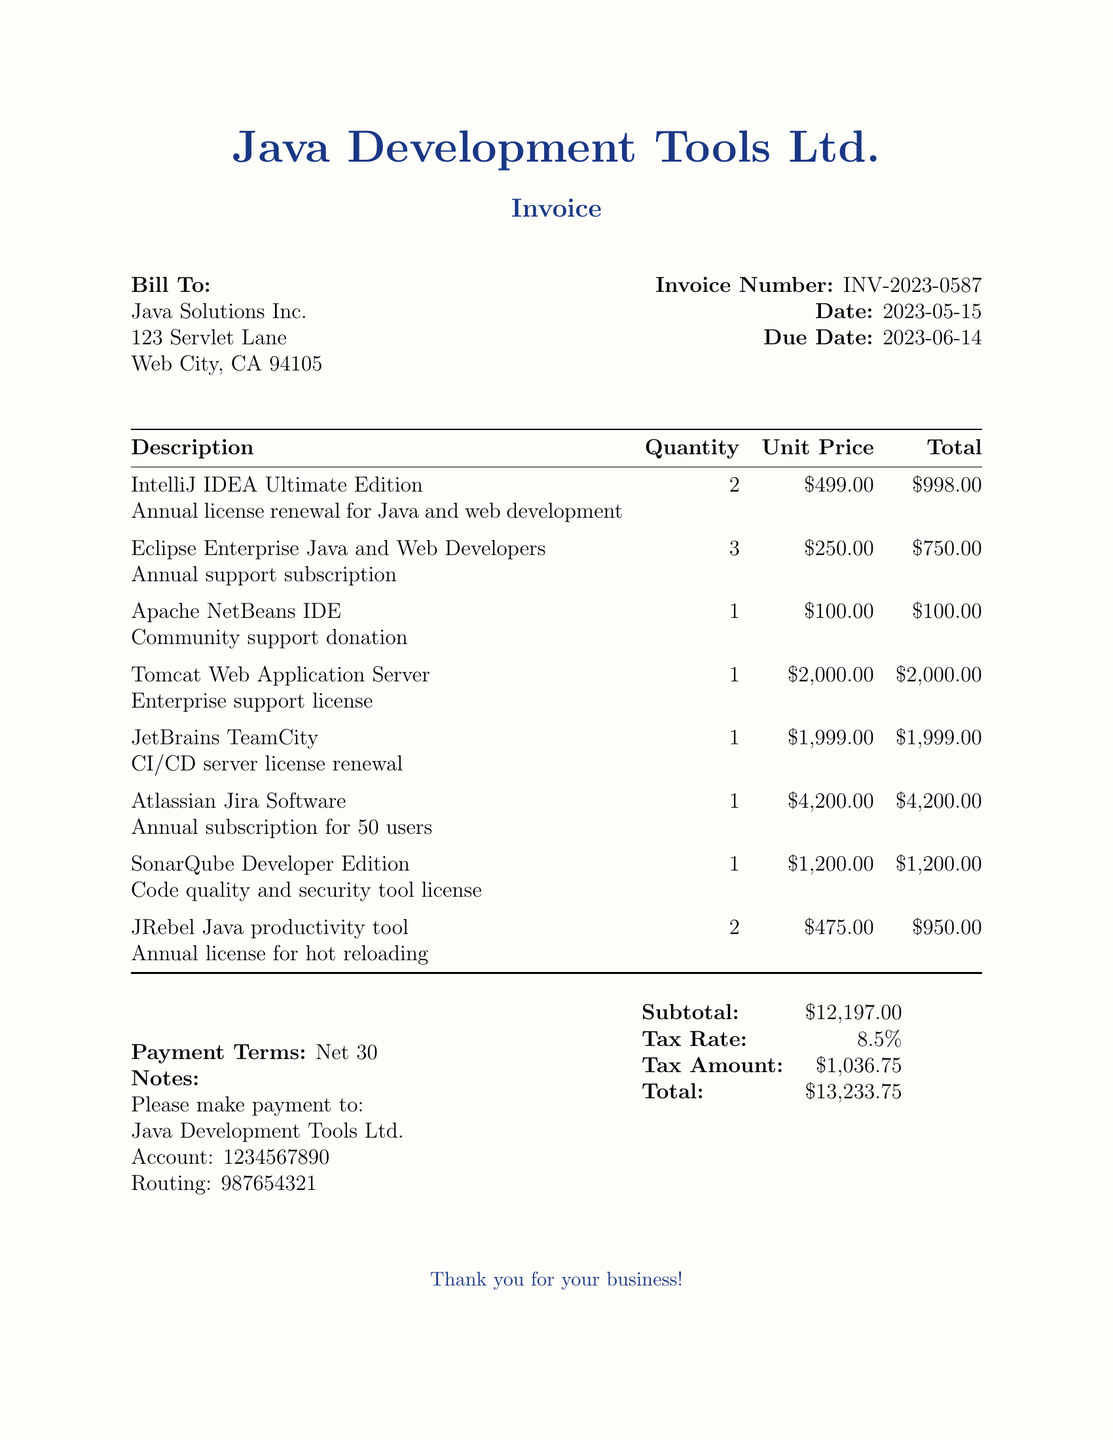What is the invoice number? The invoice number is explicitly stated at the top of the document.
Answer: INV-2023-0587 What is the total amount due? The total amount is the final total listed at the bottom of the invoice.
Answer: $13,233.75 What is the due date for payment? The due date is mentioned alongside the invoice date.
Answer: 2023-06-14 How many licenses were renewed for IntelliJ IDEA? The quantity of IntelliJ IDEA licenses is listed in the itemized costs section.
Answer: 2 What is the description of the Tomcat Web Application Server? The description is provided directly beneath the item in the itemized list.
Answer: Enterprise support license What is the name of the customer? The customer name is prominently displayed in the billing section of the invoice.
Answer: Java Solutions Inc How much is the tax amount? The tax amount is clearly indicated in the financial summary area at the bottom of the document.
Answer: $1,036.75 What is the payment term specified in the invoice? The payment terms are listed in the notes section.
Answer: Net 30 How many users does the Atlassian Jira Software subscription cover? The user coverage is cited in the description associated with the Atlassian Jira Software item.
Answer: 50 users 